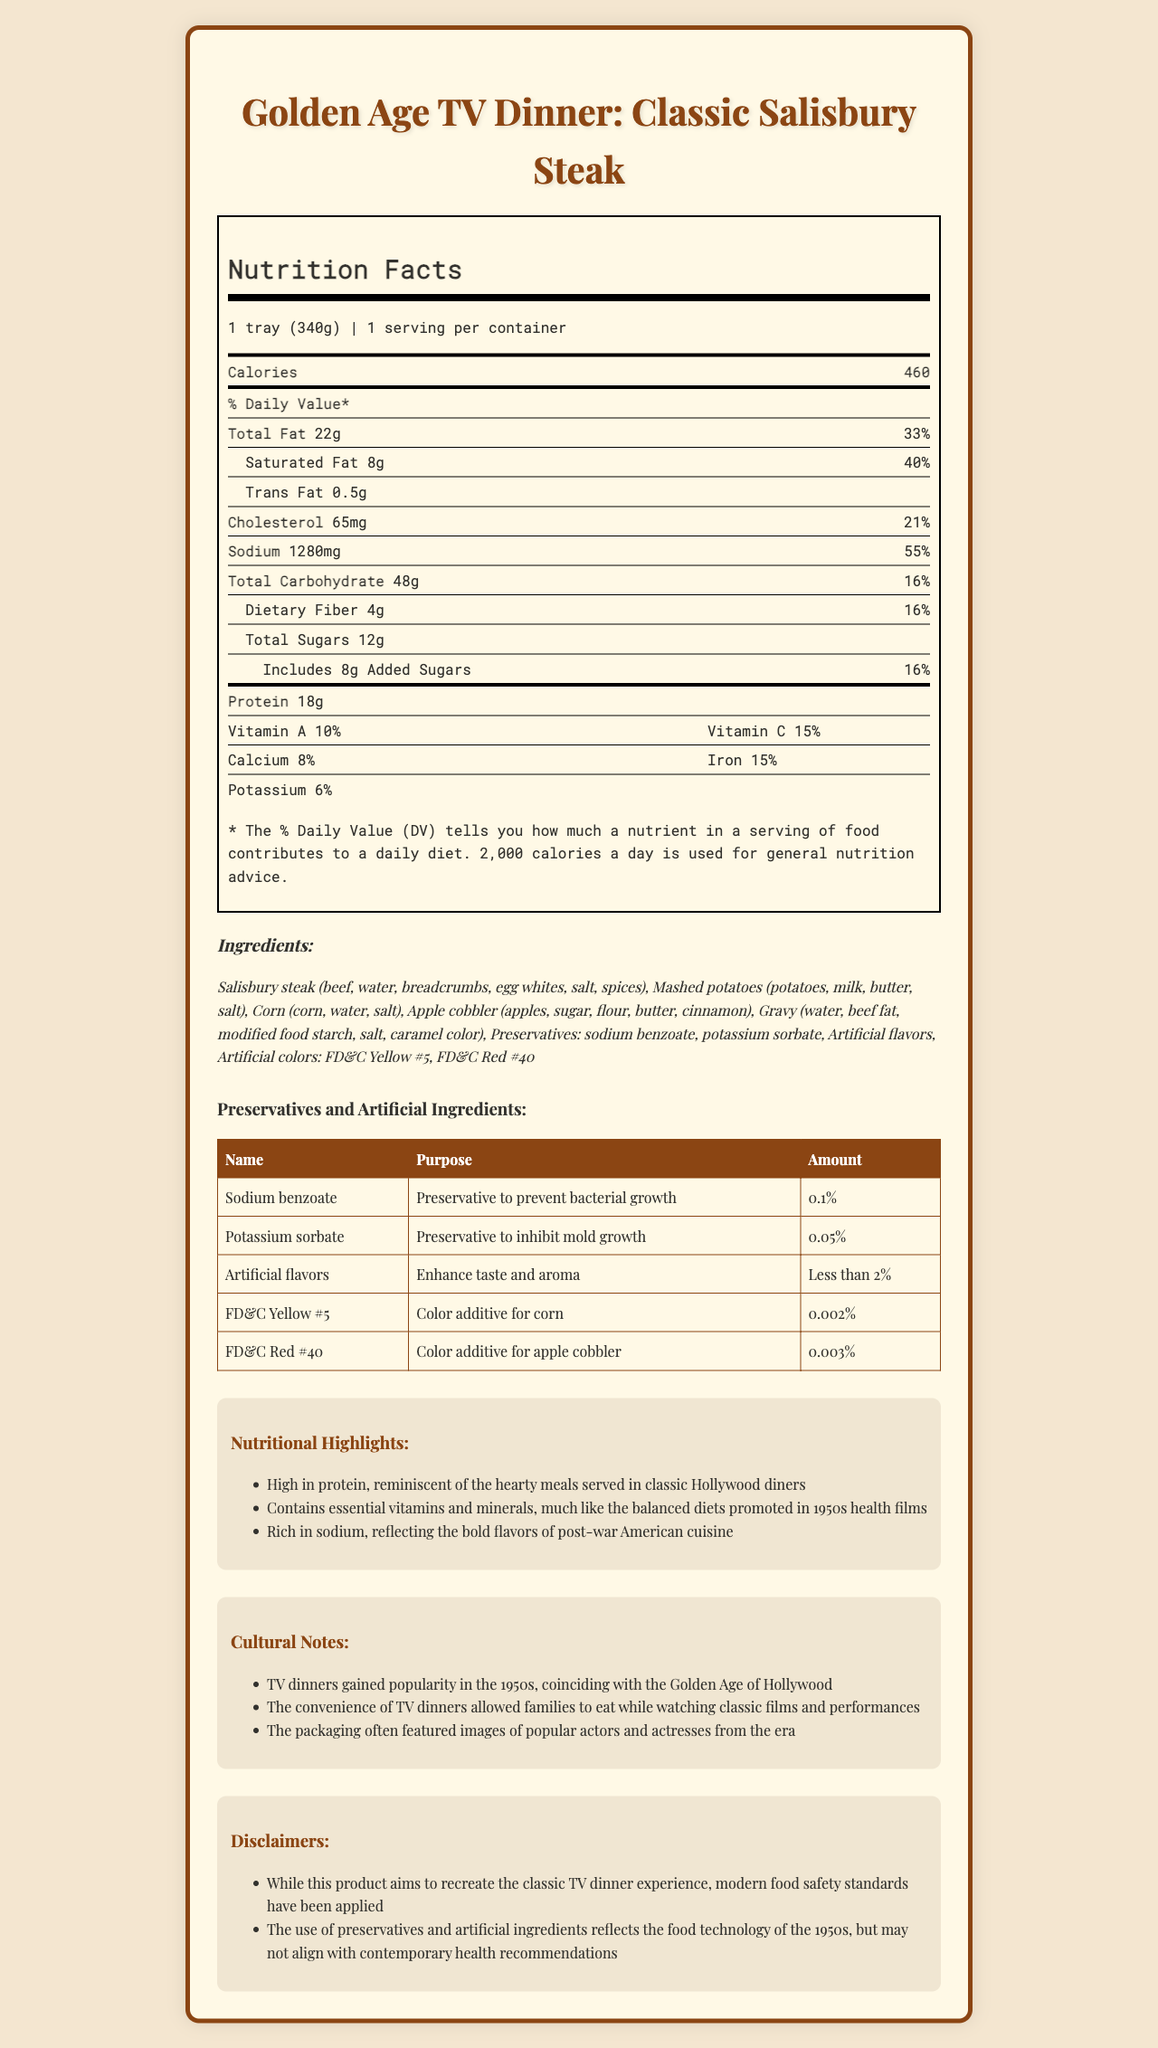what is the serving size? The document specifies the serving size as "1 tray (340g)" in the nutrition facts section.
Answer: 1 tray (340g) how many grams of total fat are in one serving? The nutrition facts label indicates that there are 22 grams of total fat per serving.
Answer: 22g what percentage of the daily value for sodium does one serving provide? The document states that one serving contains 1280mg of sodium, which is 56% of the daily value.
Answer: 56% how much added sugar is in the TV dinner? The nutrition facts label lists 8 grams of added sugars per serving.
Answer: 8g which preservatives are included in the ingredients list? The ingredients section mentions these preservatives specifically.
Answer: Sodium benzoate, Potassium sorbate what is the purpose of sodium benzoate? A. Enhance taste B. Prevent bacterial growth C. Add color The document states that sodium benzoate is used as a preservative to prevent bacterial growth.
Answer: B which artificial ingredient is used as a color additive for corn? A. FD&C Yellow #5 B. FD&C Red #40 C. Artificial flavors FD&C Yellow #5 is listed as the color additive for corn.
Answer: A is this TV dinner high in sodium? The document highlights that the TV dinner is "rich in sodium," and 1280mg represents 56% of the daily value.
Answer: Yes how does this product reflect the food trends of the 1950s? The cultural notes mention that TV dinners became popular in the 1950s and that the use of preservatives and artificial ingredients reflects the food technology of that era.
Answer: It contains preservatives and artificial ingredients and mirrors the convenience and flavors of post-war American cuisine. how many servings are in this container? The nutrition facts label states that there is 1 serving per container.
Answer: 1 serving what can you say about the calorie content of this meal? According to the nutrition facts, the TV dinner provides 460 calories per serving.
Answer: The meal contains 460 calories per serving. which actor or actress is featured on the packaging? The document does not mention any specific actors or actresses on the packaging.
Answer: Cannot be determined what are the main components of the Salisbury Steak? The ingredients section lists these items for the Salisbury Steak.
Answer: Beef, water, breadcrumbs, egg whites, salt, spices what nutrients are highlighted for their health benefits? The nutritional highlights mention these nutrients and their importance for a balanced diet.
Answer: Protein, Vitamin A, Vitamin C, Calcium, Iron, Potassium briefly summarize the main ideas presented in the document. The document provides an exhaustive overview of the nutritional makeup, inclusion of preservatives, cultural significance of TV dinners in the 1950s, and modern-day disclaimers about the use of certain ingredients.
Answer: The document describes the nutritional content, ingredients, and cultural relevance of the Golden Age TV Dinner: Classic Salisbury Steak. It highlights the meal's rich sodium content, reminiscent of 1950s cuisine, uses preservatives and artificial colors to recreate the classic experience, and notes the popularity of TV dinners during that era. 